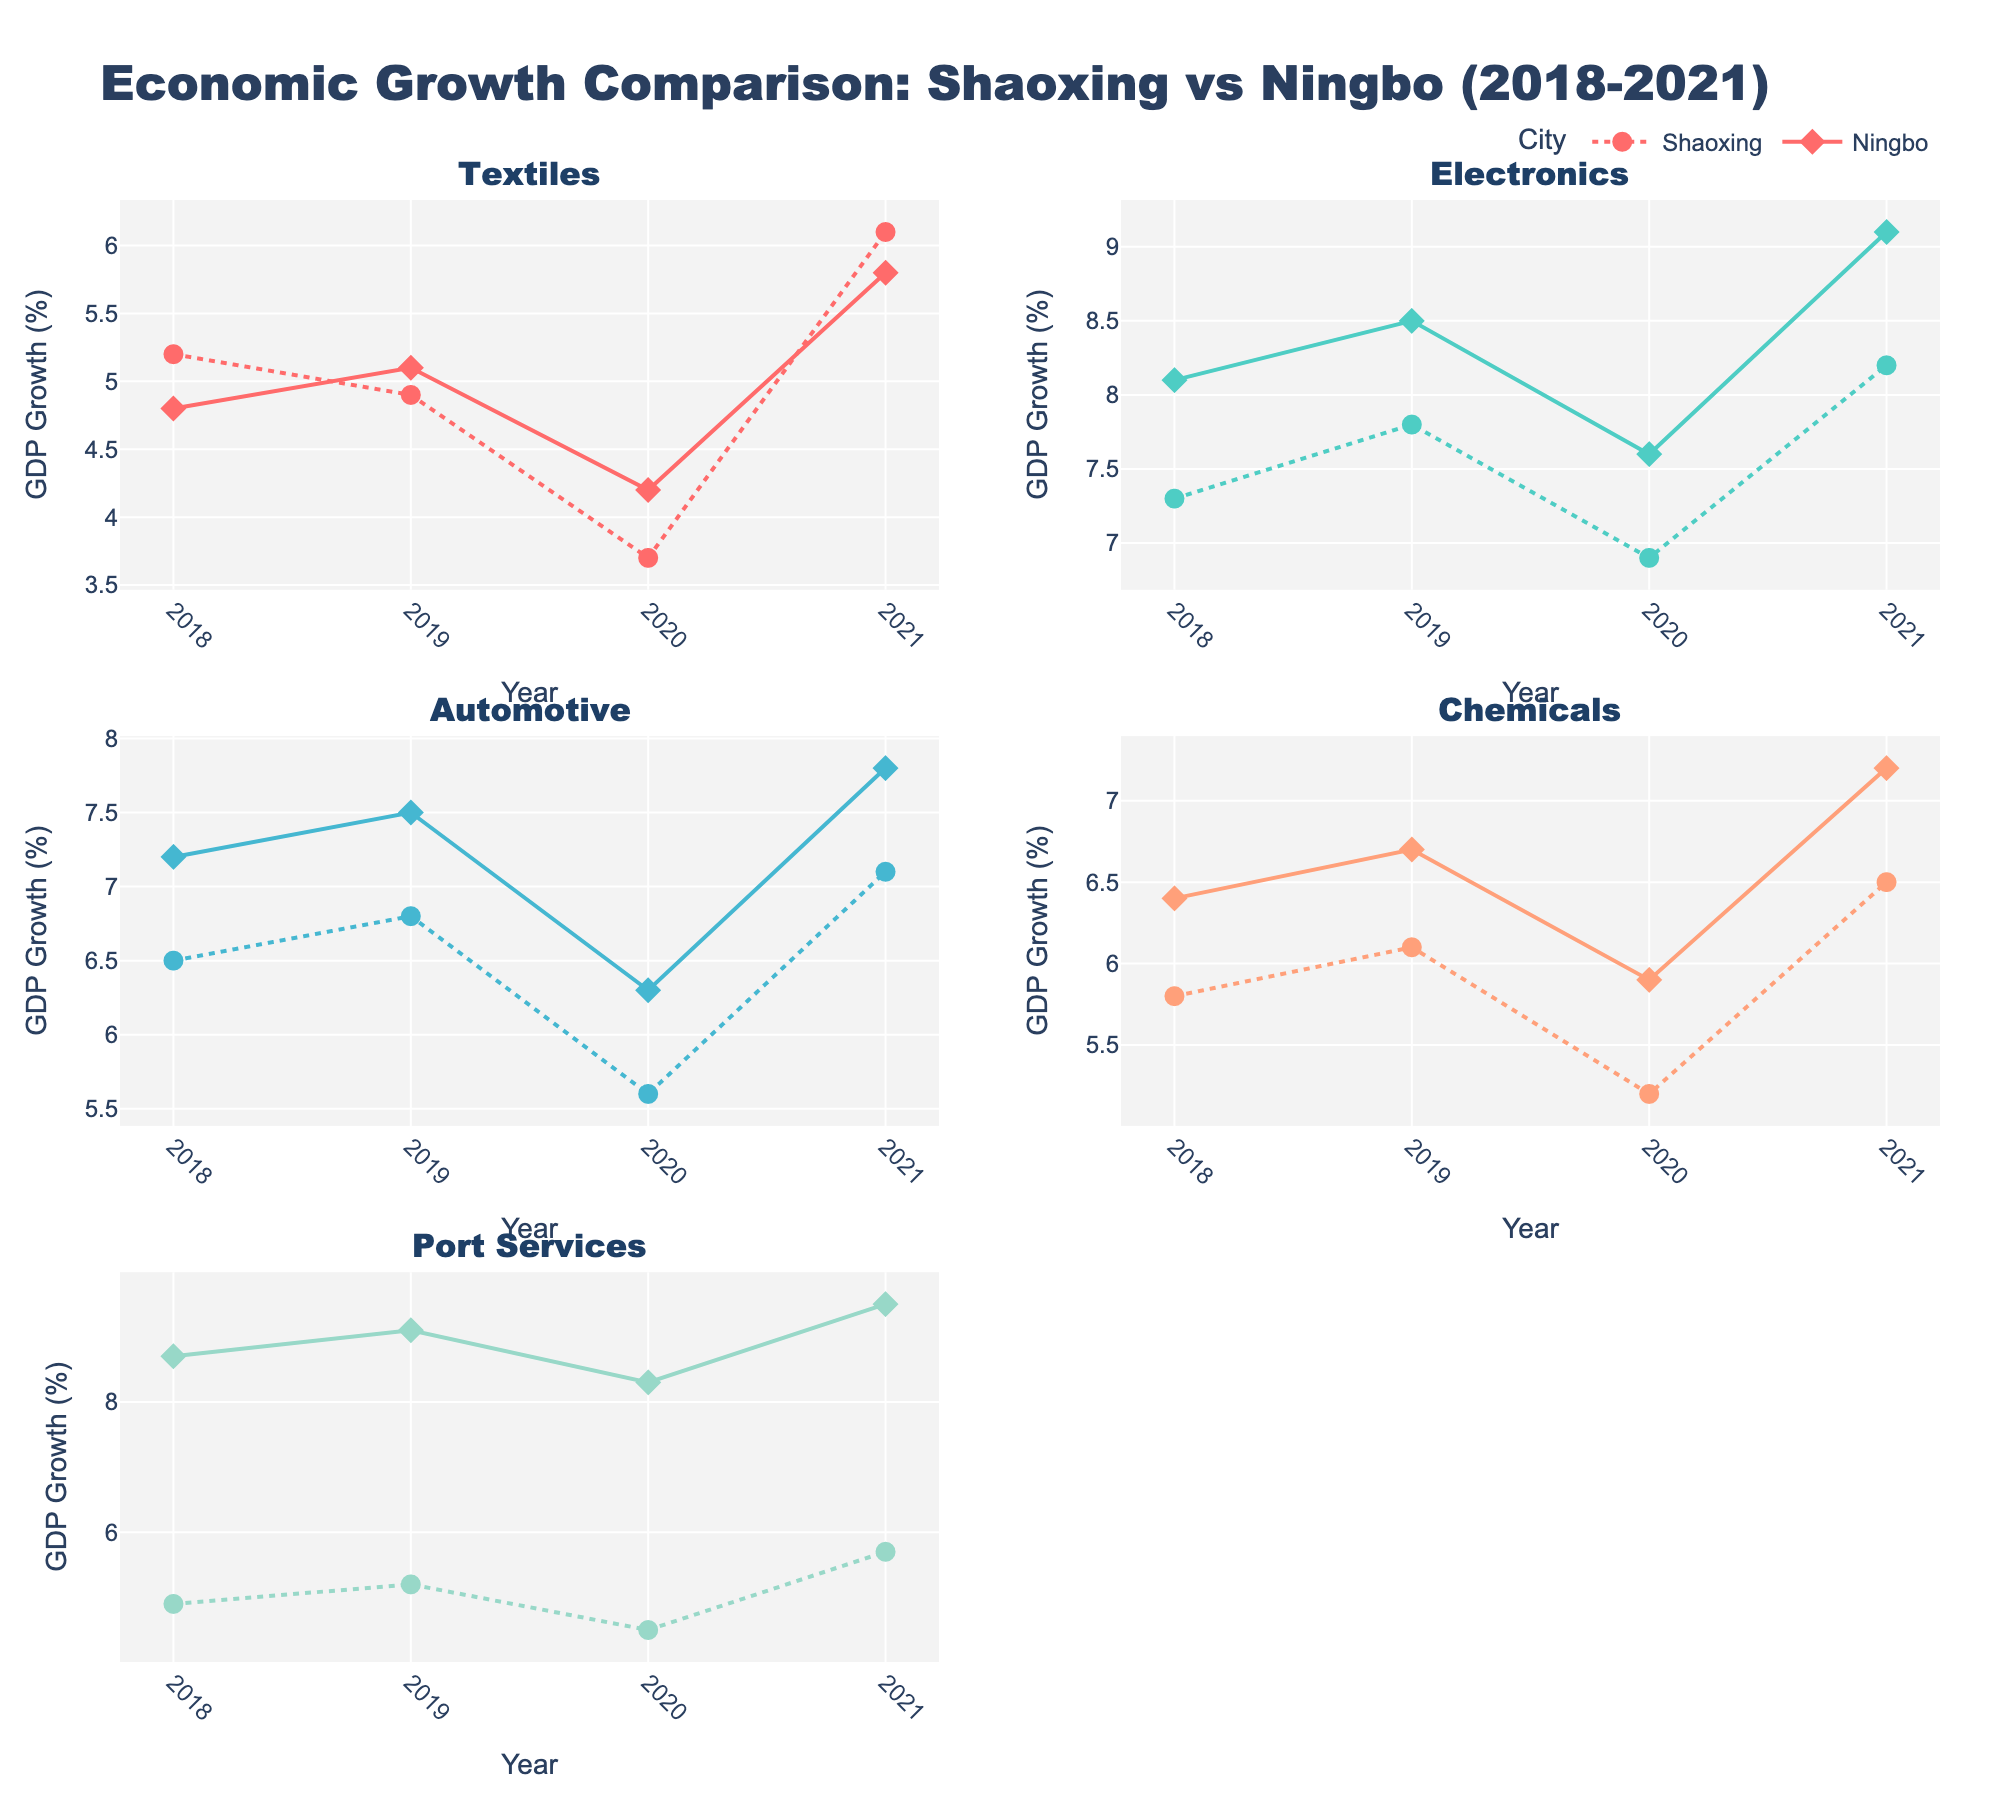What is the title of the figure? The title of the figure is located at the very top and reads "Economic Growth Comparison: Shaoxing vs Ningbo (2018-2021)."
Answer: Economic Growth Comparison: Shaoxing vs Ningbo (2018-2021) Which industry in Ningbo showed the highest GDP growth rate in 2021? By examining the markers for Ningbo in each subplot for the year 2021, it can be seen that the Port Services industry shows the highest GDP growth rate.
Answer: Port Services In which year did Shaoxing's Automotive industry experience the lowest GDP growth rate? Looking at the data points for Shaoxing's Automotive industry, the lowest GDP growth rate is observed in 2020.
Answer: 2020 How much higher was Ningbo's GDP growth rate for Port Services compared to Shaoxing in 2020? By comparing the GDP growth rates for Port Services in 2020 from the figure, Ningbo's rate was 8.3% and Shaoxing's was 4.5%. The difference is 8.3% - 4.5% = 3.8%.
Answer: 3.8% Between 2018 and 2021, which industry experienced the most consistent growth in both Shaoxing and Ningbo? Consistent growth implies minimal fluctuations. By comparing the trends for each industry, the Electronics industry shows the most consistent growth in both cities.
Answer: Electronics How many years does the data span? The x-axis of each subplot shows data from 2018 to 2021, which is a span of 4 years.
Answer: 4 years Which industry shows the greatest difference in GDP growth between Shaoxing and Ningbo on average over the four years? By calculating the average difference in GDP growth rates per year across both cities for each industry, Port Services shows the highest average difference.
Answer: Port Services What is the average GDP growth rate of the Chemicals industry in Shaoxing from 2018 to 2021? The GDP growth rates for the Chemicals industry in Shaoxing over the years are 5.8%, 6.1%, 5.2%, and 6.5%. The average is calculated as (5.8 + 6.1 + 5.2 + 6.5) / 4 = 5.9%.
Answer: 5.9% Did both cities’ Electronics industries experience a rise in GDP growth from 2020 to 2021? By examining the data points for Electronics, both Shaoxing (6.9% to 8.2%) and Ningbo (7.6% to 9.1%) experienced an increase in growth from 2020 to 2021.
Answer: Yes 